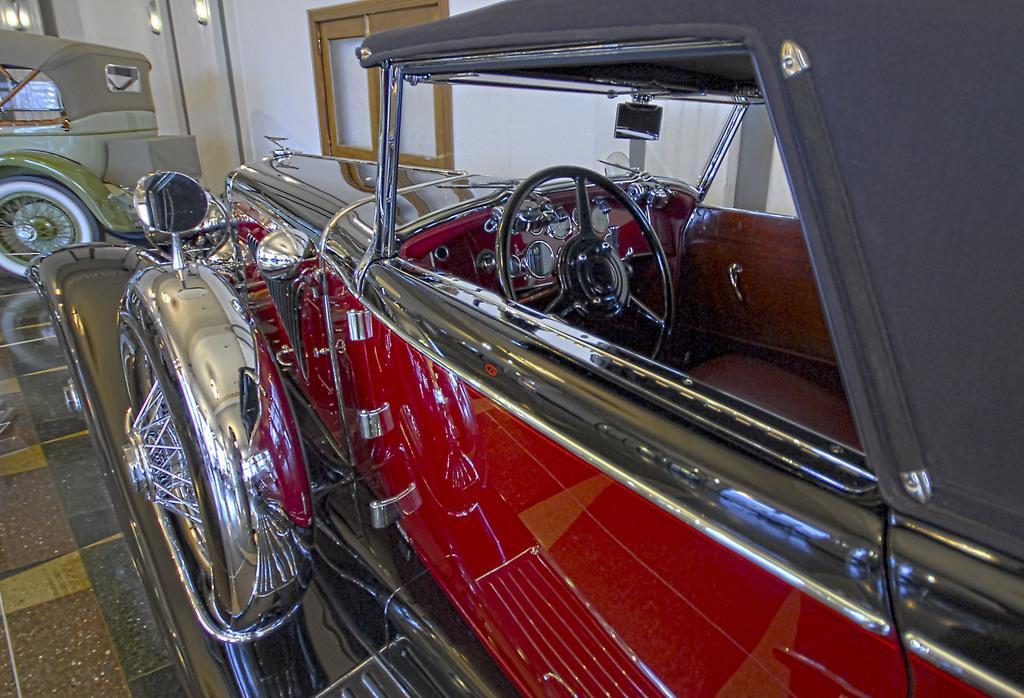Please provide a concise description of this image. In this image there are vintage cars parked on the floor. Behind them there is a wall. In the center there is a glass window to the wall. At the top there are lambs to the wall. 